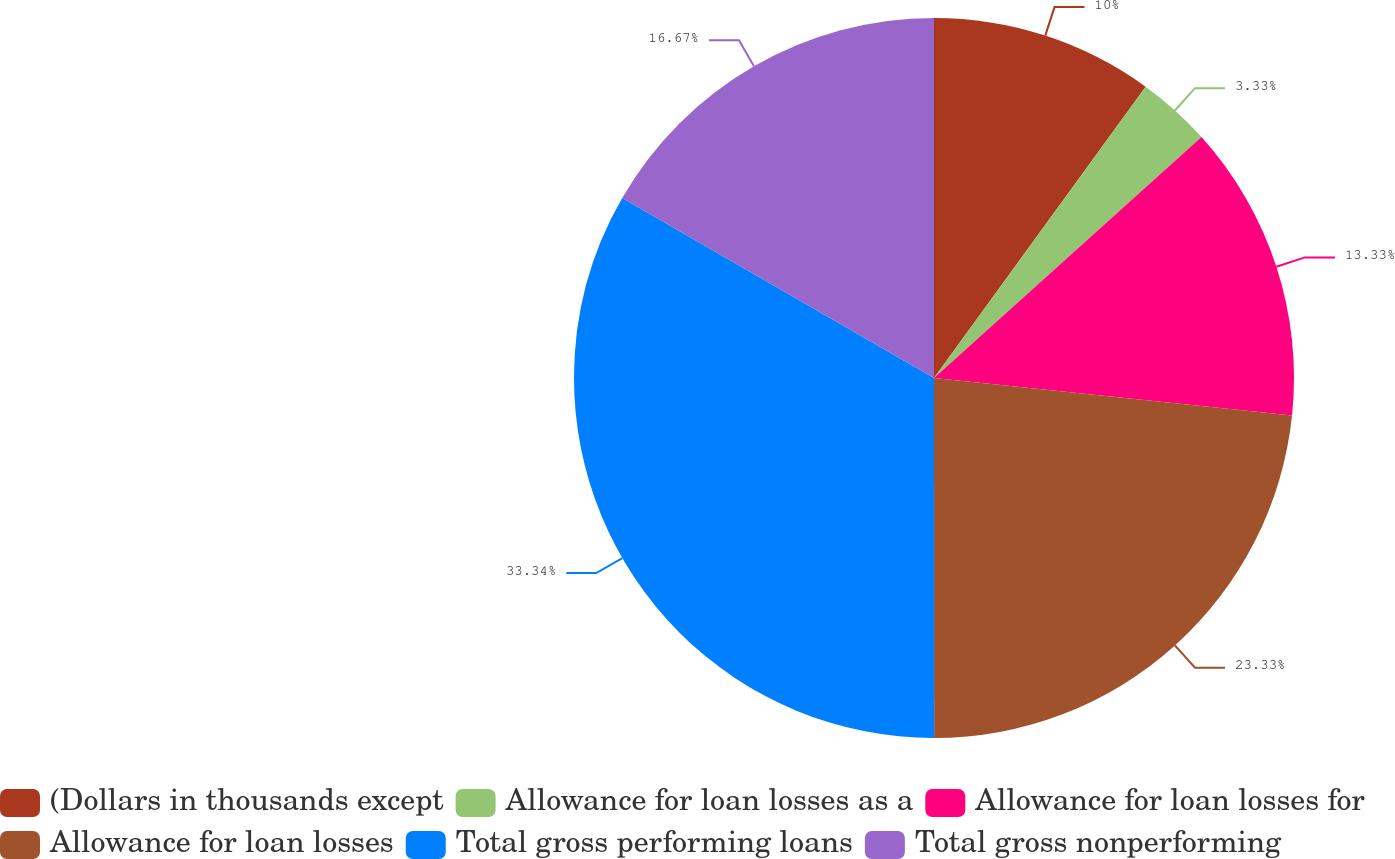<chart> <loc_0><loc_0><loc_500><loc_500><pie_chart><fcel>(Dollars in thousands except<fcel>Allowance for loan losses as a<fcel>Allowance for loan losses for<fcel>Allowance for loan losses<fcel>Total gross performing loans<fcel>Total gross nonperforming<nl><fcel>10.0%<fcel>3.33%<fcel>13.33%<fcel>23.33%<fcel>33.33%<fcel>16.67%<nl></chart> 